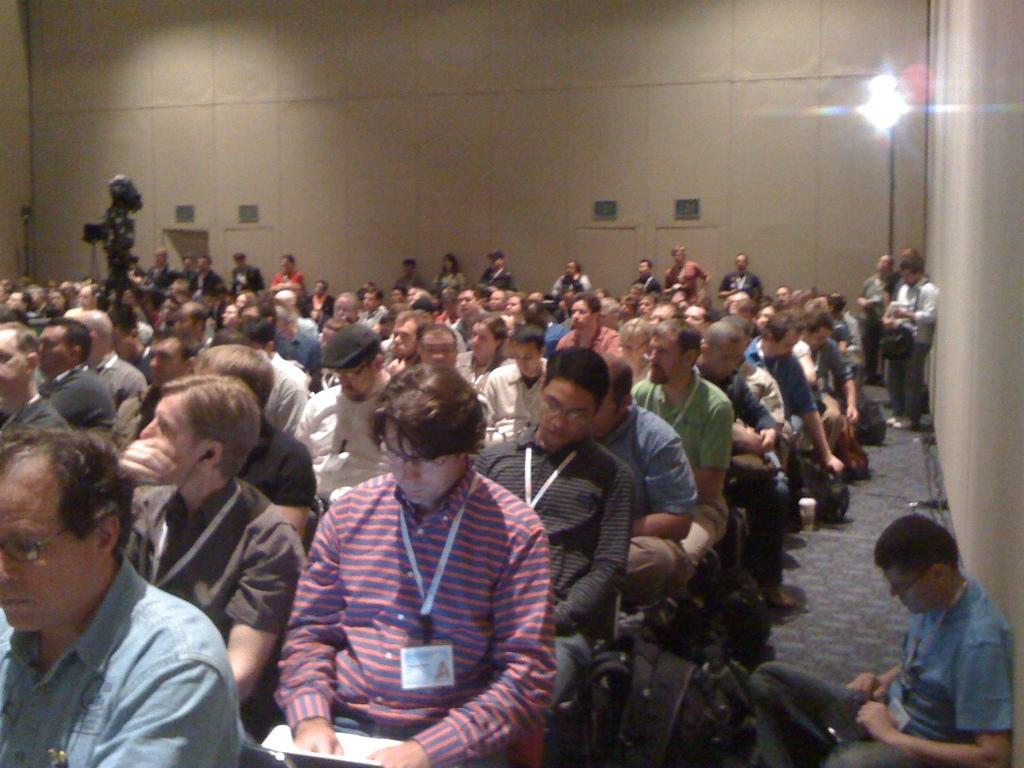Please provide a concise description of this image. In the image there are many people sitting on the chairs inside a room. To the right bottom of the image there is a man with blue t-shirt is sitting on the floor. In the background there are few people standing. And behind them there is a wall with doors and exit boards on it. And to the right side corner there is a wall, beside the wall there is a stand with lights. 